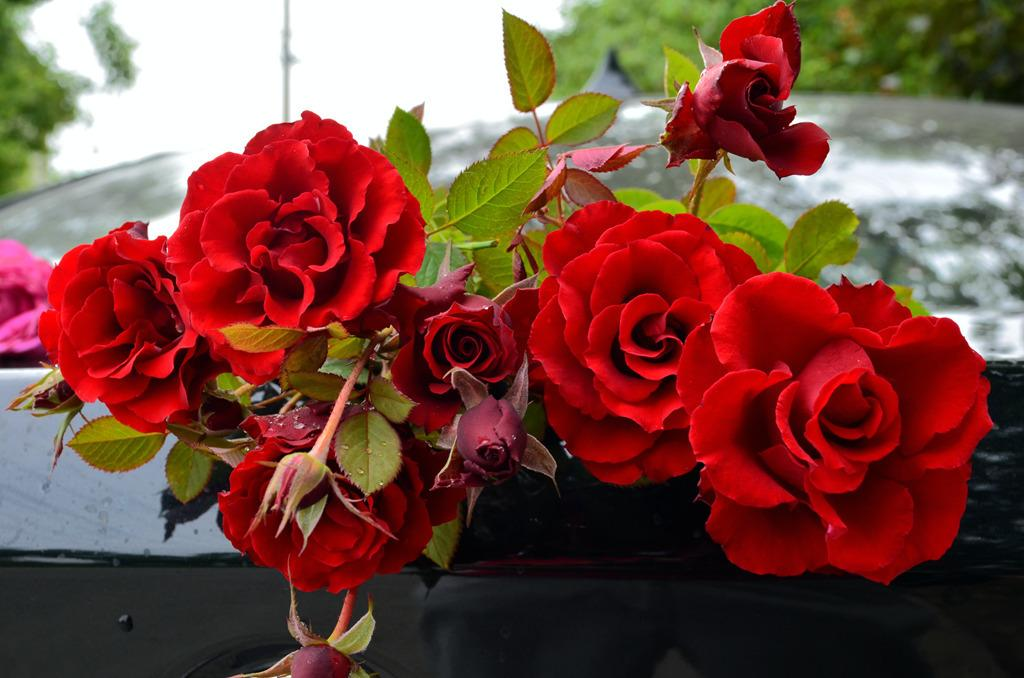What type of plants are in the foreground of the image? There are rose plants in the foreground of the image. What can be seen in the background of the image? There are trees and the sky visible in the background of the image. What might be the location of the image based on the plants and trees? The image may have been taken in a garden, given the presence of rose plants and trees. What type of meal is being prepared by the lawyer in the downtown area in the image? There is no lawyer, downtown area, or meal preparation present in the image. 